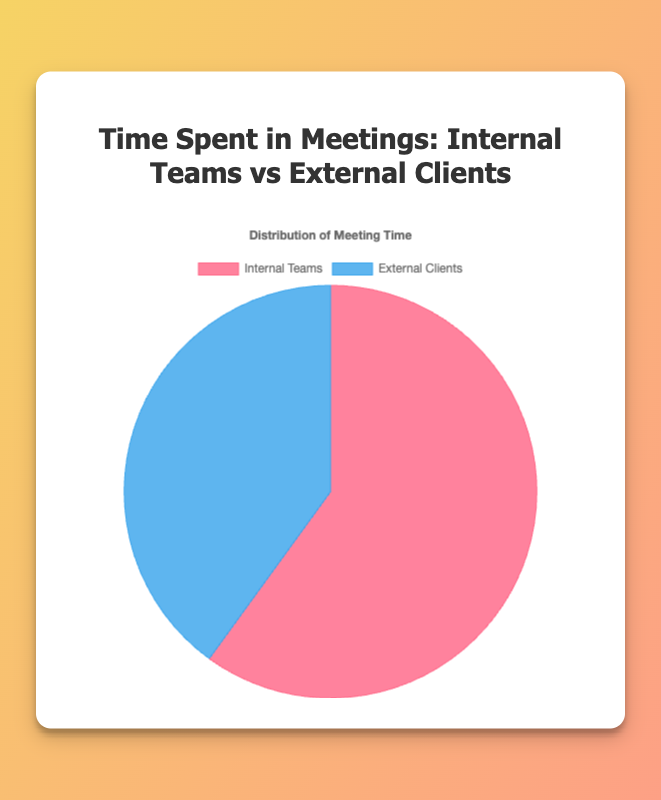What percentage of time is spent in meetings with internal teams? We see from the pie chart that the segment for Internal Teams is labeled with 60%. Therefore, 60% of the time is spent in meetings with internal teams.
Answer: 60% What is the difference in time spent between internal teams and external clients? The chart shows 60% for internal teams and 40% for external clients. The difference is calculated by subtracting the smaller percentage from the larger one: 60% - 40% = 20%.
Answer: 20% Which category occupies a larger portion of the pie chart? By visually inspecting the chart and looking at the percentages, we see that 'Internal Teams' has a larger portion (60%) compared to 'External Clients' (40%).
Answer: Internal Teams If the total meeting time is 15 hours, how many hours are spent with external clients? The external clients' portion is 40%. To find the number of hours, we calculate 40% of 15 hours: 0.40 * 15 = 6 hours.
Answer: 6 hours What is the ratio of time spent in meetings with internal teams to external clients? The chart shows 60% for internal teams and 40% for external clients. The ratio is therefore 60:40, which simplifies to 3:2.
Answer: 3:2 Which segment of the pie chart is represented in blue color? By visually inspecting the chart, the 'External Clients' segment is represented in blue.
Answer: External Clients 